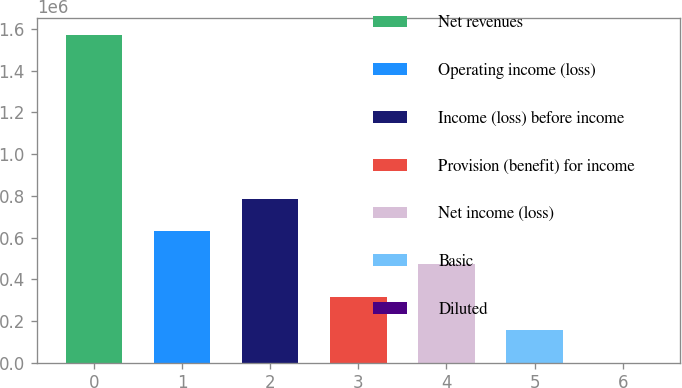<chart> <loc_0><loc_0><loc_500><loc_500><bar_chart><fcel>Net revenues<fcel>Operating income (loss)<fcel>Income (loss) before income<fcel>Provision (benefit) for income<fcel>Net income (loss)<fcel>Basic<fcel>Diluted<nl><fcel>1.57323e+06<fcel>629294<fcel>786617<fcel>314647<fcel>471970<fcel>157324<fcel>0.87<nl></chart> 